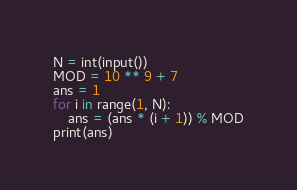Convert code to text. <code><loc_0><loc_0><loc_500><loc_500><_Python_>N = int(input())
MOD = 10 ** 9 + 7
ans = 1
for i in range(1, N):
    ans = (ans * (i + 1)) % MOD
print(ans)</code> 